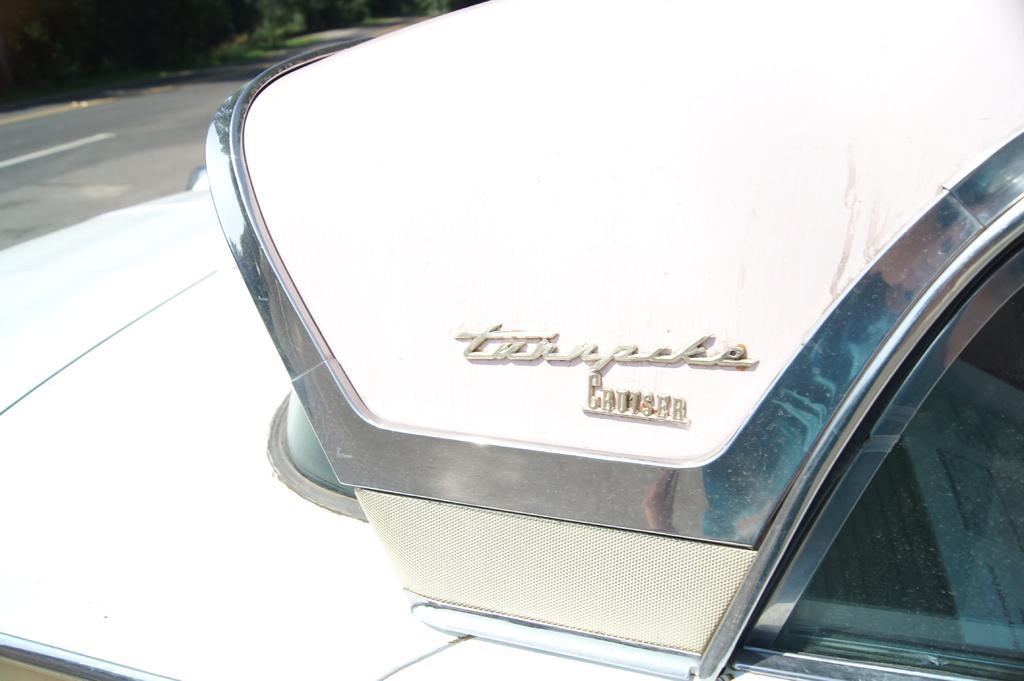In one or two sentences, can you explain what this image depicts? In this picture I can see a white color vehicle in front and I see something is written on it. In the background I can see the road and few plants. 